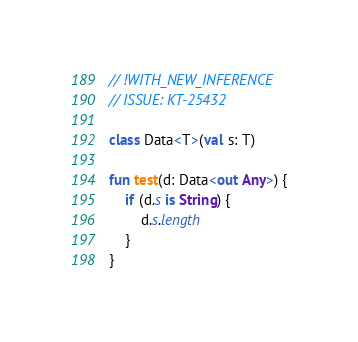<code> <loc_0><loc_0><loc_500><loc_500><_Kotlin_>// !WITH_NEW_INFERENCE
// ISSUE: KT-25432

class Data<T>(val s: T)

fun test(d: Data<out Any>) {
    if (d.s is String) {
        d.s.length
    }
}

</code> 